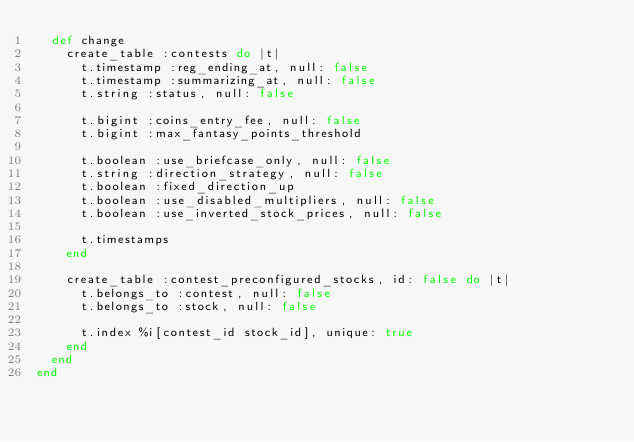<code> <loc_0><loc_0><loc_500><loc_500><_Ruby_>  def change
    create_table :contests do |t|
      t.timestamp :reg_ending_at, null: false
      t.timestamp :summarizing_at, null: false
      t.string :status, null: false

      t.bigint :coins_entry_fee, null: false
      t.bigint :max_fantasy_points_threshold

      t.boolean :use_briefcase_only, null: false
      t.string :direction_strategy, null: false
      t.boolean :fixed_direction_up
      t.boolean :use_disabled_multipliers, null: false
      t.boolean :use_inverted_stock_prices, null: false

      t.timestamps
    end

    create_table :contest_preconfigured_stocks, id: false do |t|
      t.belongs_to :contest, null: false
      t.belongs_to :stock, null: false

      t.index %i[contest_id stock_id], unique: true
    end
  end
end
</code> 